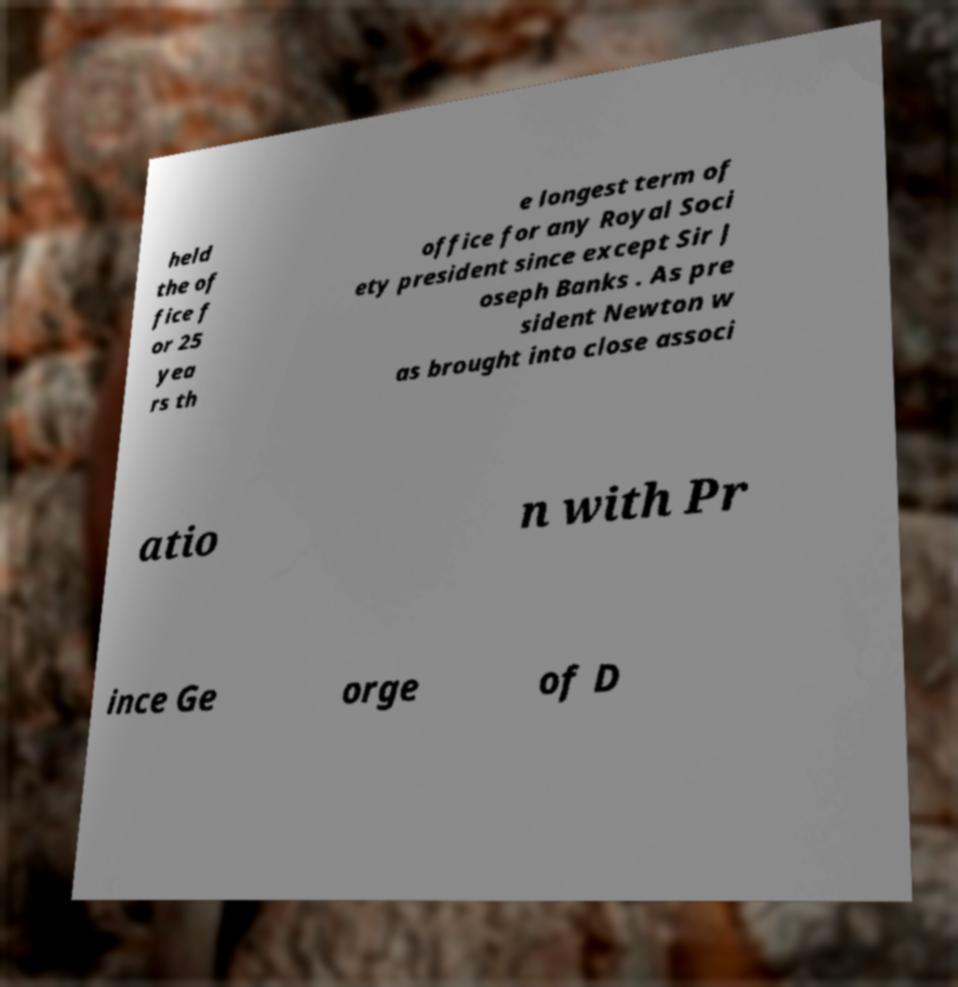Could you extract and type out the text from this image? held the of fice f or 25 yea rs th e longest term of office for any Royal Soci ety president since except Sir J oseph Banks . As pre sident Newton w as brought into close associ atio n with Pr ince Ge orge of D 